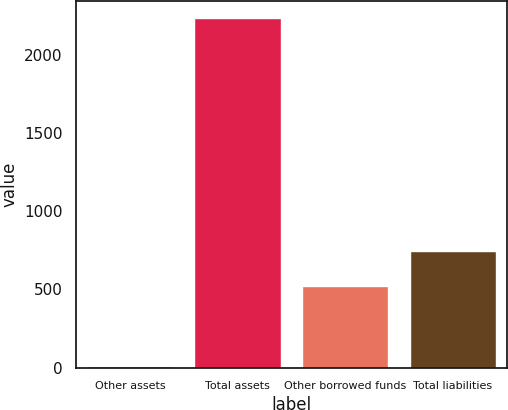Convert chart to OTSL. <chart><loc_0><loc_0><loc_500><loc_500><bar_chart><fcel>Other assets<fcel>Total assets<fcel>Other borrowed funds<fcel>Total liabilities<nl><fcel>9<fcel>2235<fcel>523<fcel>745.6<nl></chart> 